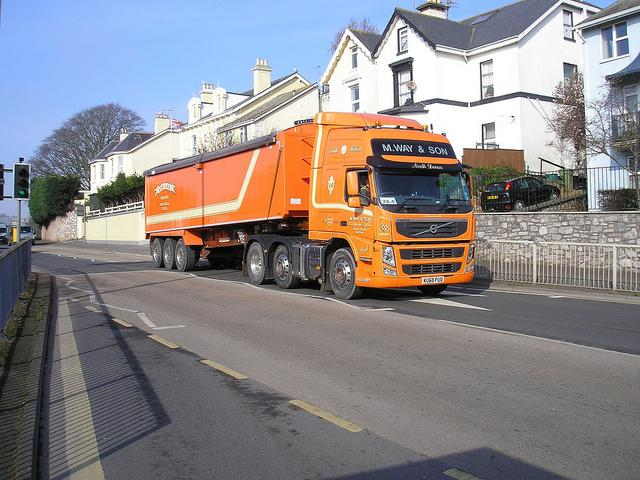What type of truck is this? Please explain your reasoning. commercial. This truck is massive and a regular driver would not choose it. the name of the company is on the front. 